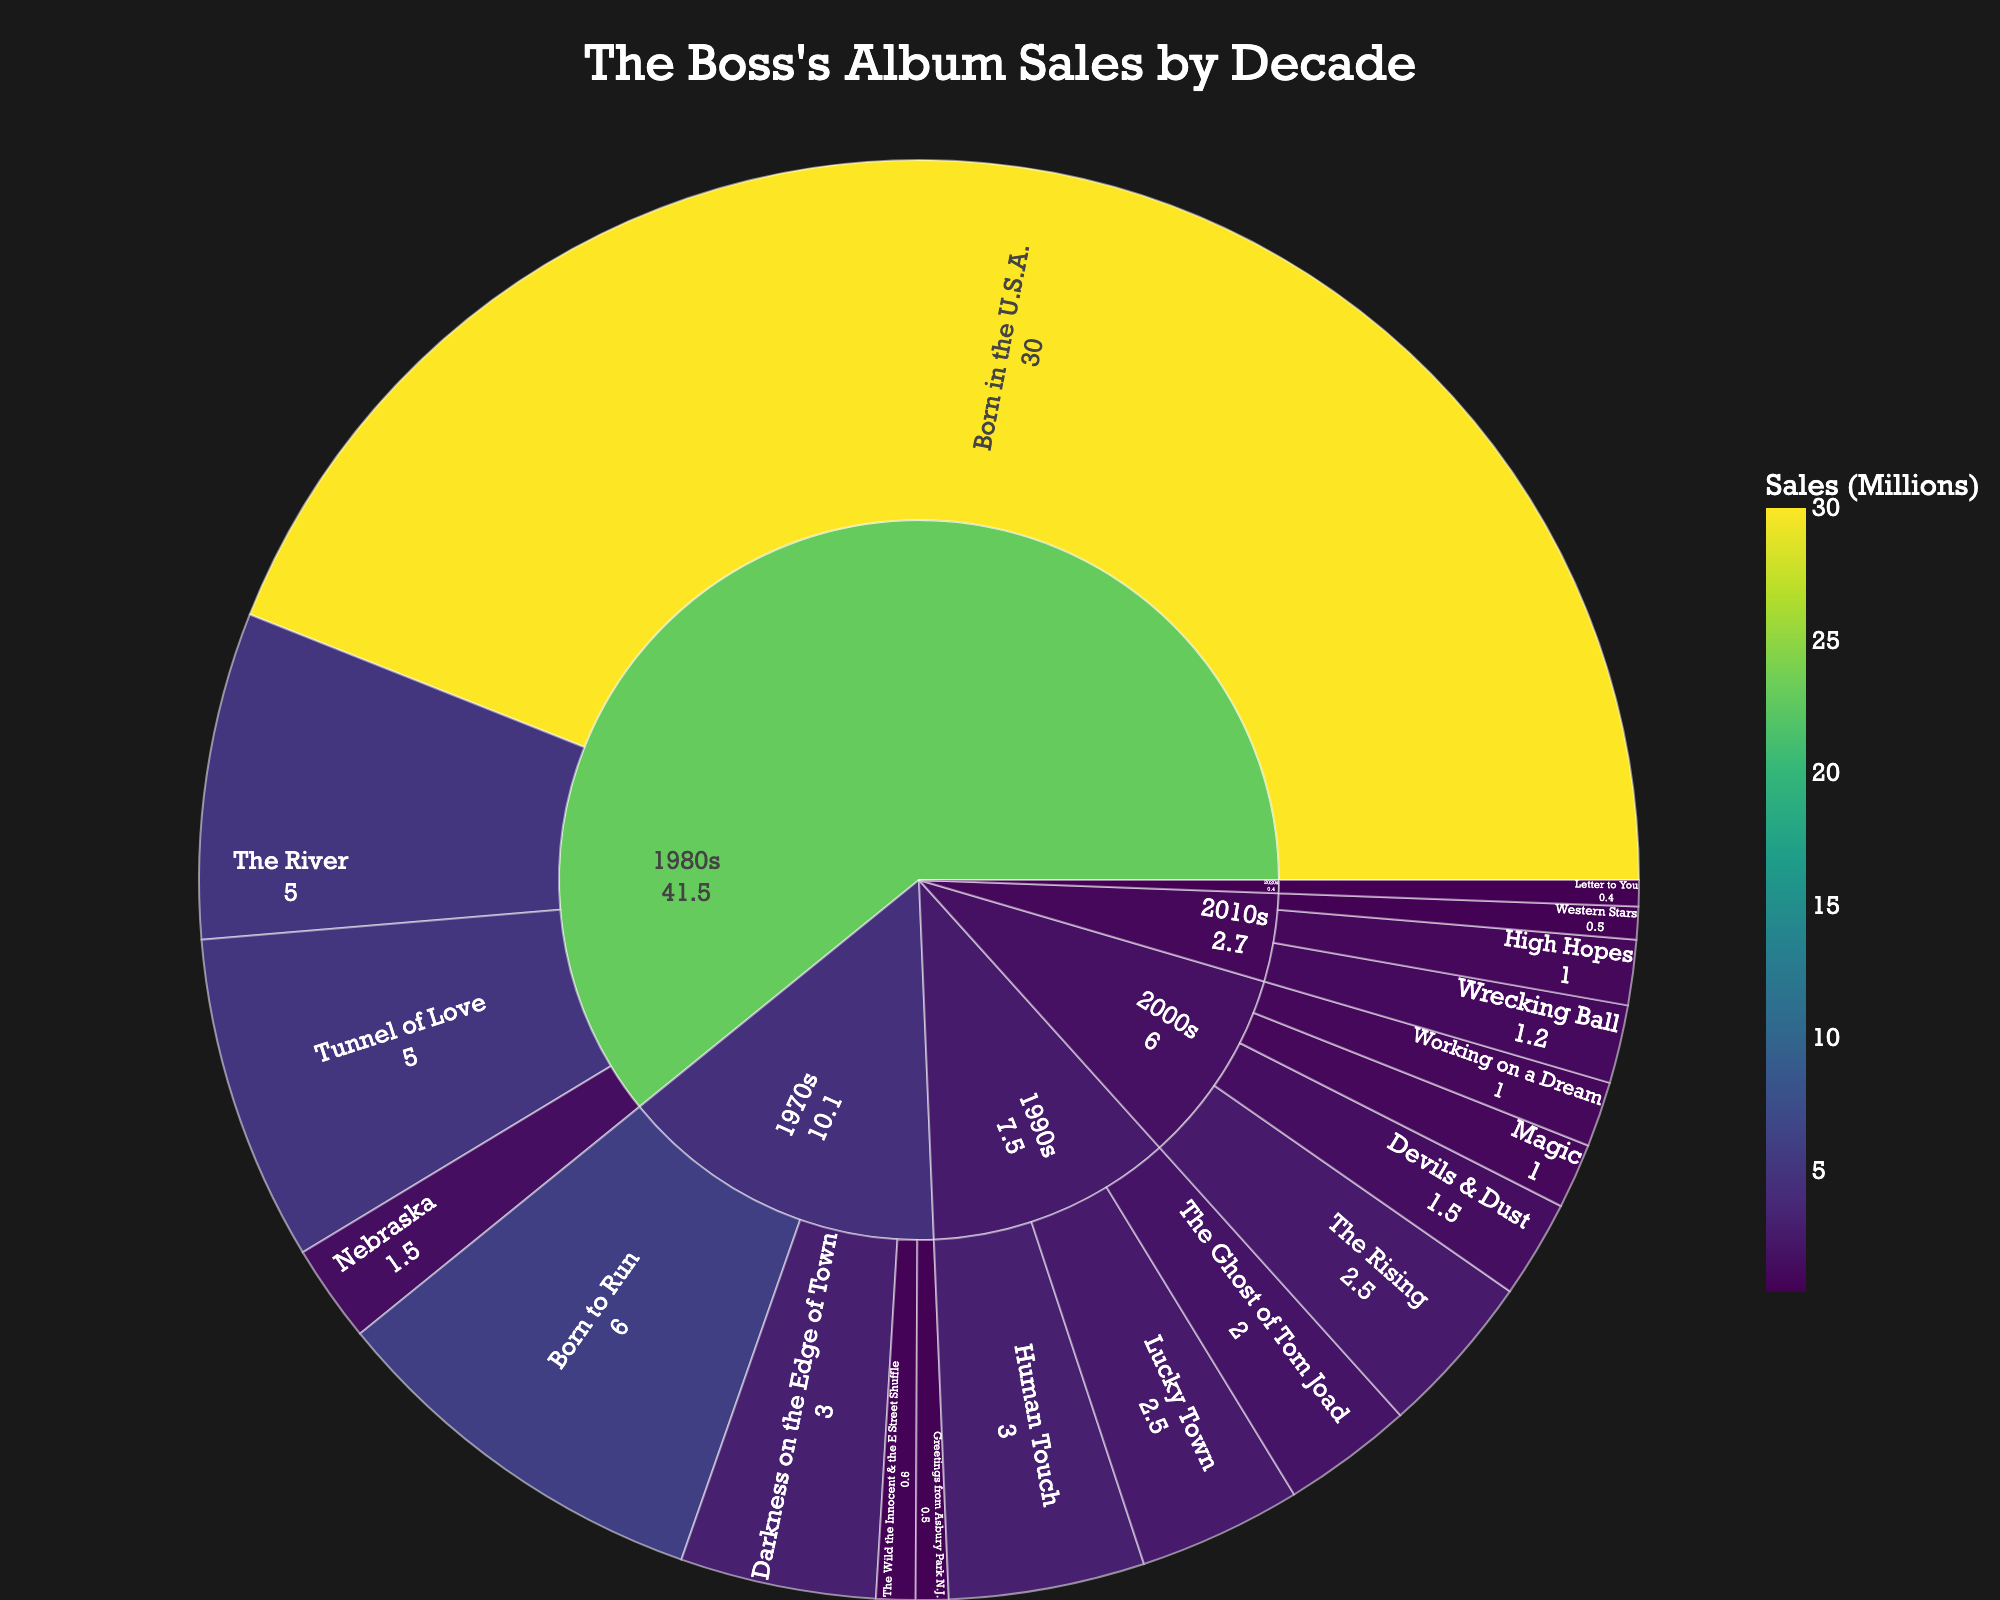What is the title of the figure? The title is prominently displayed at the top of the plot. The font is larger and usually centered to grab attention.
Answer: The Boss's Album Sales by Decade Which album in the 1980s has the highest sales? In the sunburst plot, the size of each segment is proportional to the sales. By identifying the largest segment within the 1980s section, we can determine the album with the highest sales.
Answer: Born in the U.S.A What is the total sales for albums in the 1970s decade? Sum the sales values for all albums listed under the 1970s. The albums are "Greetings from Asbury Park N.J." (500,000), "The Wild the Innocent & the E Street Shuffle" (600,000), "Born to Run" (6,000,000), and "Darkness on the Edge of Town" (3,000,000), giving a total of (500,000 + 600,000 + 6,000,000 + 3,000,000).
Answer: 10,100,000 Which album in the 2010s has the lowest sales? Within the 2010s section, look for the smallest segment. This indicates the album with the lowest sales in that decade.
Answer: Western Stars How do the sales of "Born in the U.S.A." compare to "Born to Run"? Observe the segments representing "Born in the U.S.A." and "Born to Run". The size difference visually indicates which has higher sales. "Born in the U.S.A." segment is significantly larger than "Born to Run".
Answer: Born in the U.S.A. has significantly higher sales What is the combined sales for the most sold album in each decade? Identify the top-selling album for each decade and sum their sales. These albums are "Born to Run" (6,000,000 - 1970s), "Born in the U.S.A." (30,000,000 - 1980s), "Human Touch" (3,000,000 - 1990s), "The Rising" (2,500,000 - 2000s), and "Wrecking Ball" (1,200,000 - 2010s). The combined sales is 6,000,000 + 30,000,000 + 3,000,000 + 2,500,000 + 1,200,000.
Answer: 42,700,000 Which decade has the highest total album sales? Compare the combined sales for each decade. Larger sections in the sunburst plot indicate higher sales. The 1980s has a significantly larger combined section than others.
Answer: 1980s What is the average album sales for the 1990s? Sum the sales of all albums in the 1990s and divide by the number of albums. Albums: "Human Touch" (3,000,000), "Lucky Town" (2,500,000), "The Ghost of Tom Joad" (2,000,000). The total is 3,000,000 + 2,500,000 + 2,000,000 = 7,500,000, and there are 3 albums, so the average is 7,500,000 / 3.
Answer: 2,500,000 How do the sales of "The Rising" compare to "Magic"? Within the 2000s section, compare the segments for "The Rising" and "Magic". "The Rising" segment is larger than "Magic", indicating higher sales.
Answer: The Rising has higher sales What decade does the album "Devils & Dust" belong to? Trace the pathway of the album segment "Devils & Dust" to its parent section, which is the decade it belongs to.
Answer: 2000s 